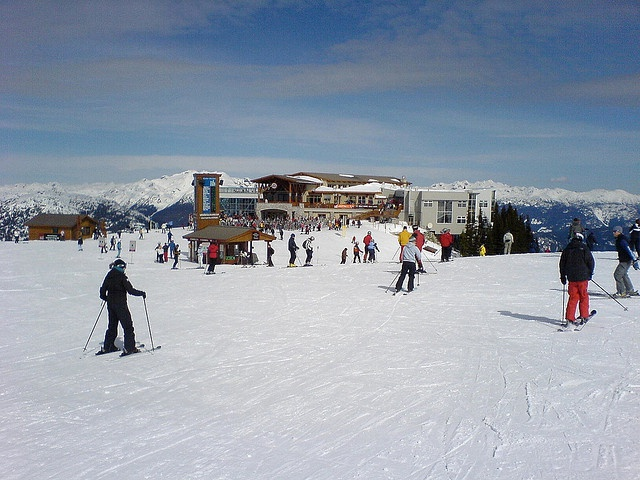Describe the objects in this image and their specific colors. I can see people in gray, lightgray, black, and darkgray tones, people in gray, black, lightgray, and darkgray tones, people in gray, black, brown, and maroon tones, people in gray, black, navy, and lightgray tones, and people in gray, black, darkgray, and lightgray tones in this image. 